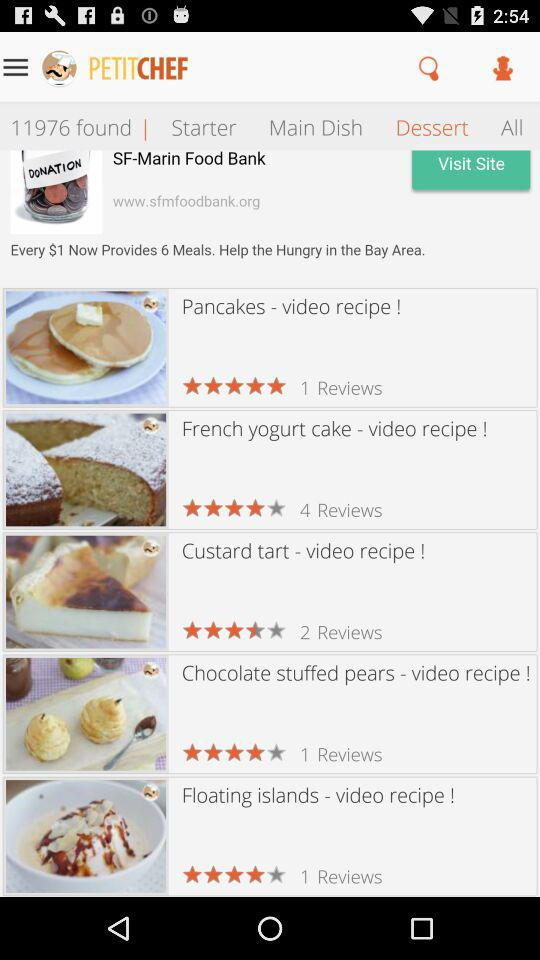How many reviews are there for Custard Tart? There are 2 reviews for Custard Tart. 